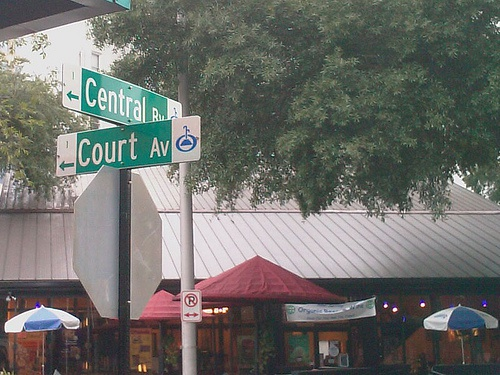Describe the objects in this image and their specific colors. I can see stop sign in black, darkgray, and gray tones, umbrella in black, brown, and maroon tones, umbrella in black, lightgray, lightblue, gray, and darkgray tones, umbrella in black, blue, darkgray, gray, and lightgray tones, and umbrella in black, salmon, and brown tones in this image. 